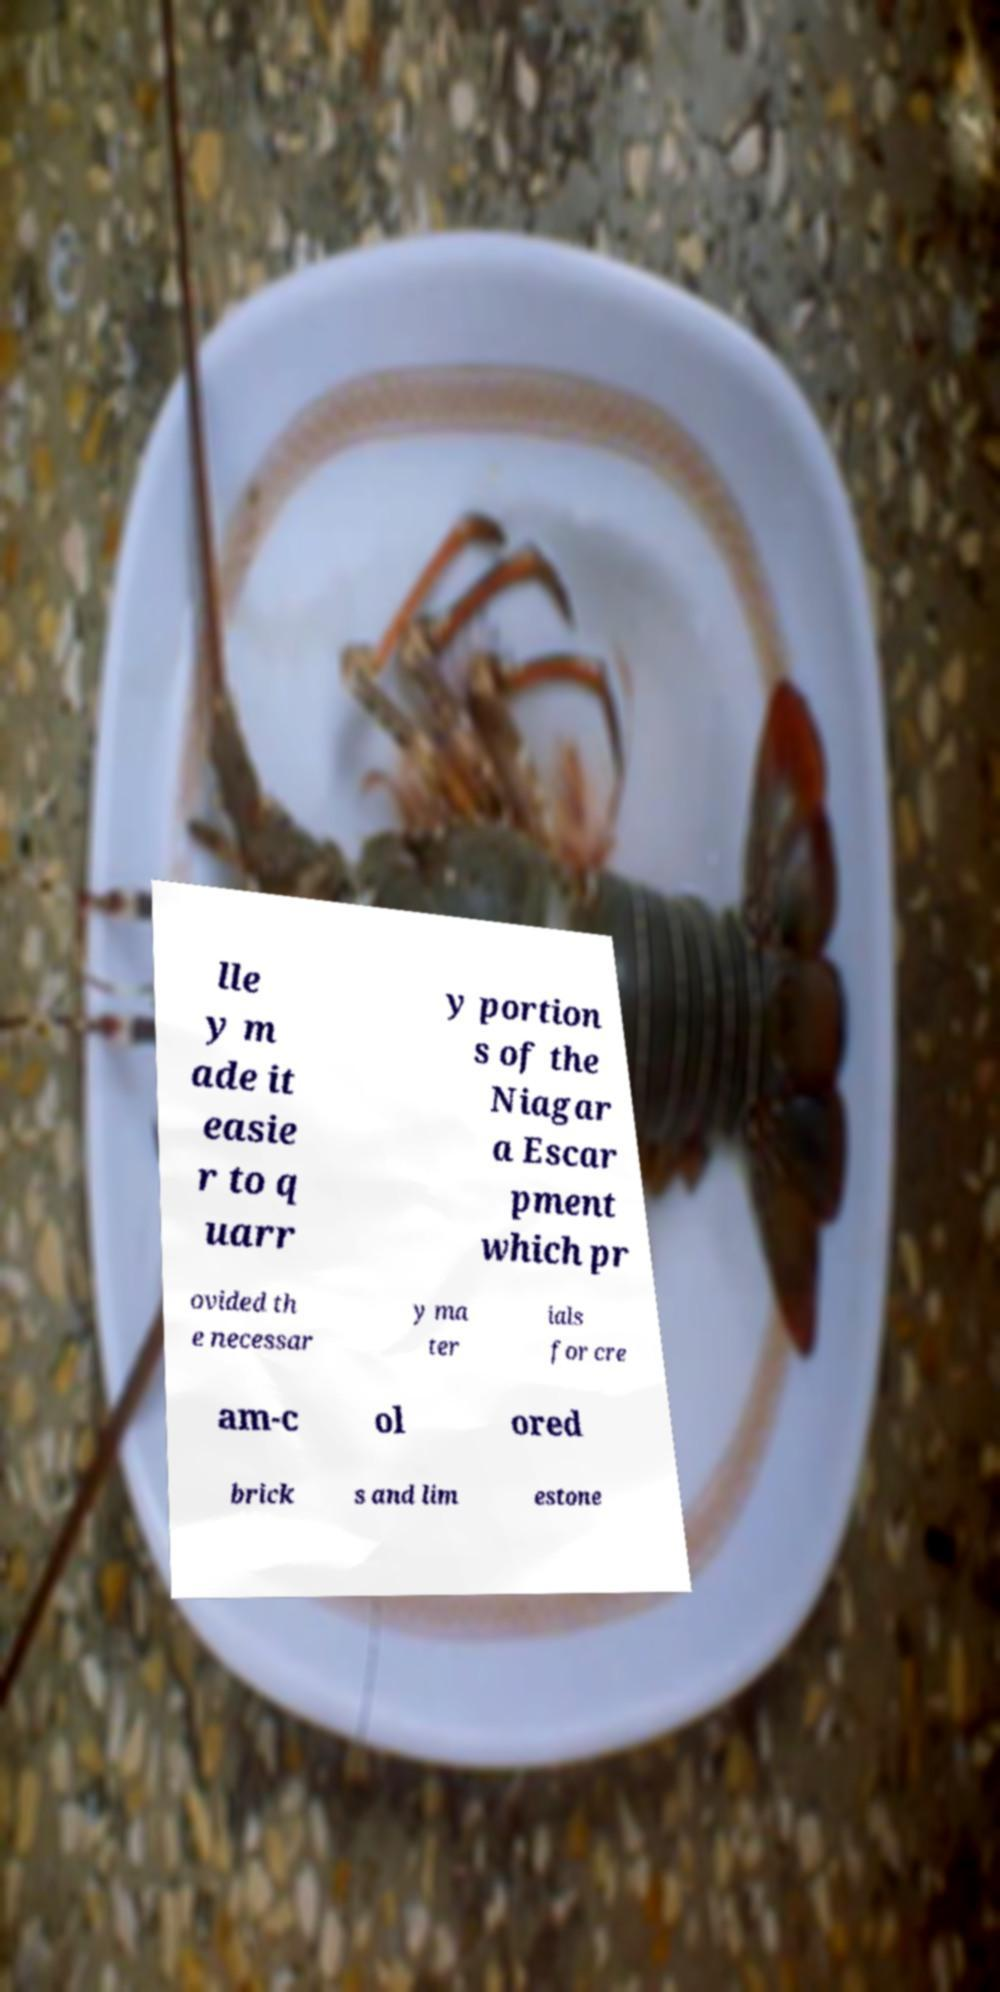Please read and relay the text visible in this image. What does it say? lle y m ade it easie r to q uarr y portion s of the Niagar a Escar pment which pr ovided th e necessar y ma ter ials for cre am-c ol ored brick s and lim estone 